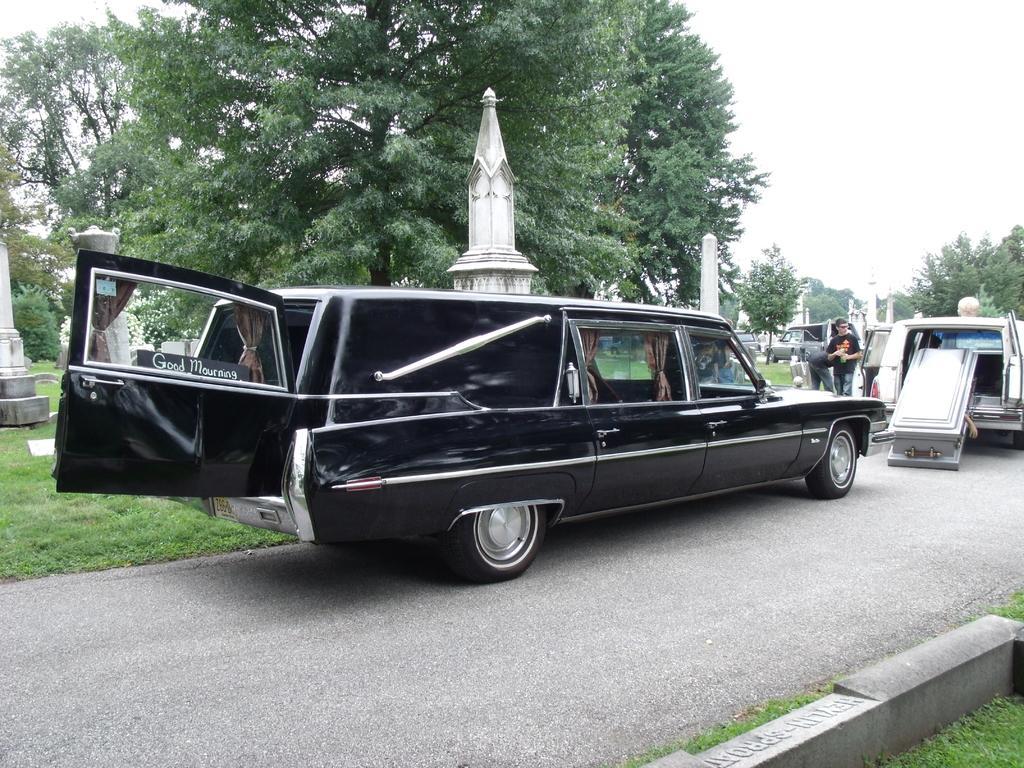Describe this image in one or two sentences. In this picture I can see vehicles on the road, there are group of people, those are looking like poles, there are trees, and in the background there is sky. 